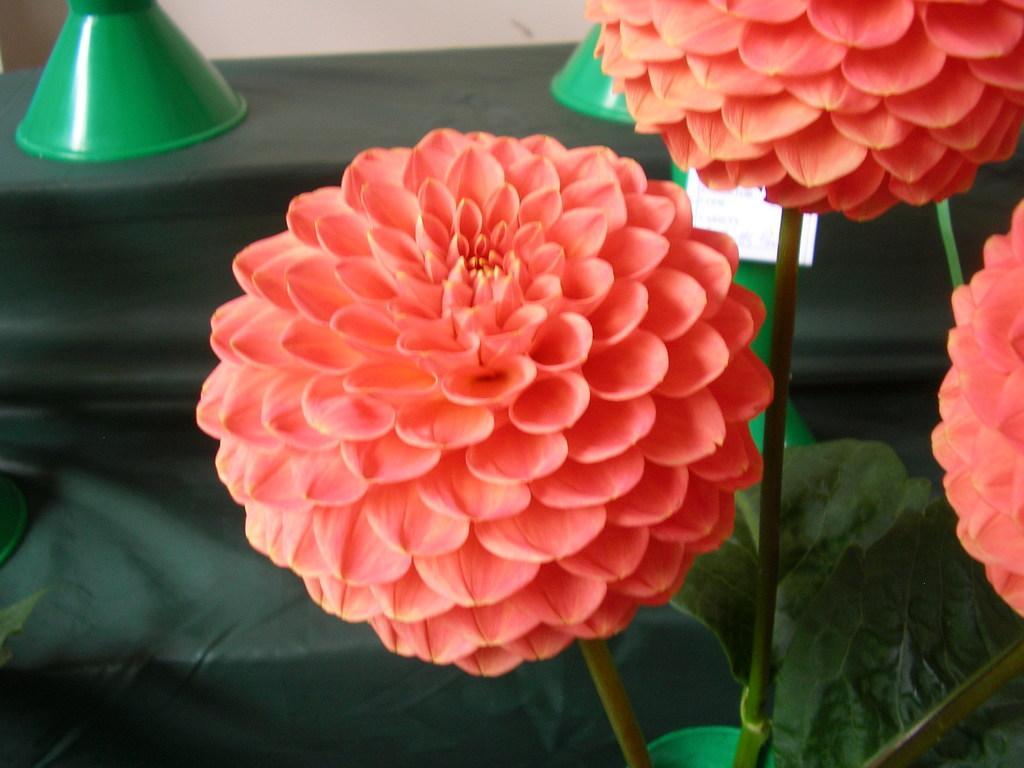Can you describe this image briefly? On the right side of this image there is a plant along with the flowers. In the background there is a table which is covered with a cloth on which there are two green color objects. 